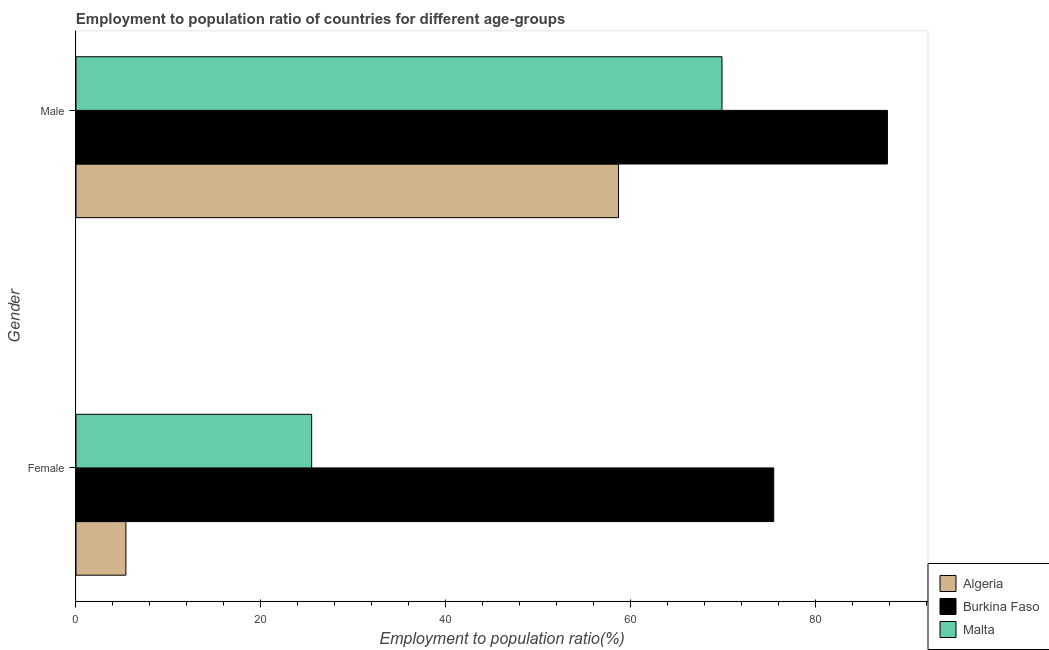How many different coloured bars are there?
Your response must be concise. 3. How many groups of bars are there?
Provide a succinct answer. 2. Are the number of bars on each tick of the Y-axis equal?
Provide a short and direct response. Yes. How many bars are there on the 1st tick from the top?
Ensure brevity in your answer.  3. What is the label of the 1st group of bars from the top?
Ensure brevity in your answer.  Male. What is the employment to population ratio(male) in Algeria?
Provide a succinct answer. 58.7. Across all countries, what is the maximum employment to population ratio(female)?
Offer a terse response. 75.5. Across all countries, what is the minimum employment to population ratio(male)?
Offer a terse response. 58.7. In which country was the employment to population ratio(male) maximum?
Your answer should be very brief. Burkina Faso. In which country was the employment to population ratio(male) minimum?
Provide a succinct answer. Algeria. What is the total employment to population ratio(female) in the graph?
Offer a very short reply. 106.4. What is the difference between the employment to population ratio(male) in Algeria and that in Burkina Faso?
Ensure brevity in your answer.  -29.1. What is the difference between the employment to population ratio(male) in Burkina Faso and the employment to population ratio(female) in Malta?
Ensure brevity in your answer.  62.3. What is the average employment to population ratio(male) per country?
Offer a very short reply. 72.13. What is the difference between the employment to population ratio(male) and employment to population ratio(female) in Malta?
Keep it short and to the point. 44.4. In how many countries, is the employment to population ratio(male) greater than 28 %?
Ensure brevity in your answer.  3. What is the ratio of the employment to population ratio(male) in Algeria to that in Malta?
Your answer should be compact. 0.84. In how many countries, is the employment to population ratio(male) greater than the average employment to population ratio(male) taken over all countries?
Provide a succinct answer. 1. What does the 1st bar from the top in Female represents?
Provide a succinct answer. Malta. What does the 2nd bar from the bottom in Female represents?
Offer a terse response. Burkina Faso. Are all the bars in the graph horizontal?
Provide a succinct answer. Yes. How many countries are there in the graph?
Make the answer very short. 3. What is the difference between two consecutive major ticks on the X-axis?
Your answer should be very brief. 20. Are the values on the major ticks of X-axis written in scientific E-notation?
Offer a terse response. No. Does the graph contain grids?
Your answer should be compact. No. How are the legend labels stacked?
Keep it short and to the point. Vertical. What is the title of the graph?
Provide a succinct answer. Employment to population ratio of countries for different age-groups. What is the label or title of the X-axis?
Offer a terse response. Employment to population ratio(%). What is the Employment to population ratio(%) in Algeria in Female?
Provide a succinct answer. 5.4. What is the Employment to population ratio(%) of Burkina Faso in Female?
Your answer should be very brief. 75.5. What is the Employment to population ratio(%) in Algeria in Male?
Your answer should be compact. 58.7. What is the Employment to population ratio(%) in Burkina Faso in Male?
Offer a terse response. 87.8. What is the Employment to population ratio(%) in Malta in Male?
Keep it short and to the point. 69.9. Across all Gender, what is the maximum Employment to population ratio(%) of Algeria?
Provide a succinct answer. 58.7. Across all Gender, what is the maximum Employment to population ratio(%) in Burkina Faso?
Make the answer very short. 87.8. Across all Gender, what is the maximum Employment to population ratio(%) in Malta?
Offer a very short reply. 69.9. Across all Gender, what is the minimum Employment to population ratio(%) in Algeria?
Give a very brief answer. 5.4. Across all Gender, what is the minimum Employment to population ratio(%) of Burkina Faso?
Keep it short and to the point. 75.5. What is the total Employment to population ratio(%) in Algeria in the graph?
Give a very brief answer. 64.1. What is the total Employment to population ratio(%) of Burkina Faso in the graph?
Provide a succinct answer. 163.3. What is the total Employment to population ratio(%) in Malta in the graph?
Provide a short and direct response. 95.4. What is the difference between the Employment to population ratio(%) in Algeria in Female and that in Male?
Provide a short and direct response. -53.3. What is the difference between the Employment to population ratio(%) of Burkina Faso in Female and that in Male?
Offer a very short reply. -12.3. What is the difference between the Employment to population ratio(%) in Malta in Female and that in Male?
Your answer should be very brief. -44.4. What is the difference between the Employment to population ratio(%) in Algeria in Female and the Employment to population ratio(%) in Burkina Faso in Male?
Give a very brief answer. -82.4. What is the difference between the Employment to population ratio(%) of Algeria in Female and the Employment to population ratio(%) of Malta in Male?
Keep it short and to the point. -64.5. What is the average Employment to population ratio(%) of Algeria per Gender?
Offer a terse response. 32.05. What is the average Employment to population ratio(%) of Burkina Faso per Gender?
Offer a very short reply. 81.65. What is the average Employment to population ratio(%) of Malta per Gender?
Provide a succinct answer. 47.7. What is the difference between the Employment to population ratio(%) of Algeria and Employment to population ratio(%) of Burkina Faso in Female?
Your response must be concise. -70.1. What is the difference between the Employment to population ratio(%) in Algeria and Employment to population ratio(%) in Malta in Female?
Your response must be concise. -20.1. What is the difference between the Employment to population ratio(%) in Burkina Faso and Employment to population ratio(%) in Malta in Female?
Ensure brevity in your answer.  50. What is the difference between the Employment to population ratio(%) in Algeria and Employment to population ratio(%) in Burkina Faso in Male?
Offer a very short reply. -29.1. What is the ratio of the Employment to population ratio(%) in Algeria in Female to that in Male?
Give a very brief answer. 0.09. What is the ratio of the Employment to population ratio(%) in Burkina Faso in Female to that in Male?
Offer a very short reply. 0.86. What is the ratio of the Employment to population ratio(%) of Malta in Female to that in Male?
Ensure brevity in your answer.  0.36. What is the difference between the highest and the second highest Employment to population ratio(%) in Algeria?
Offer a very short reply. 53.3. What is the difference between the highest and the second highest Employment to population ratio(%) in Malta?
Your response must be concise. 44.4. What is the difference between the highest and the lowest Employment to population ratio(%) of Algeria?
Your response must be concise. 53.3. What is the difference between the highest and the lowest Employment to population ratio(%) of Malta?
Give a very brief answer. 44.4. 